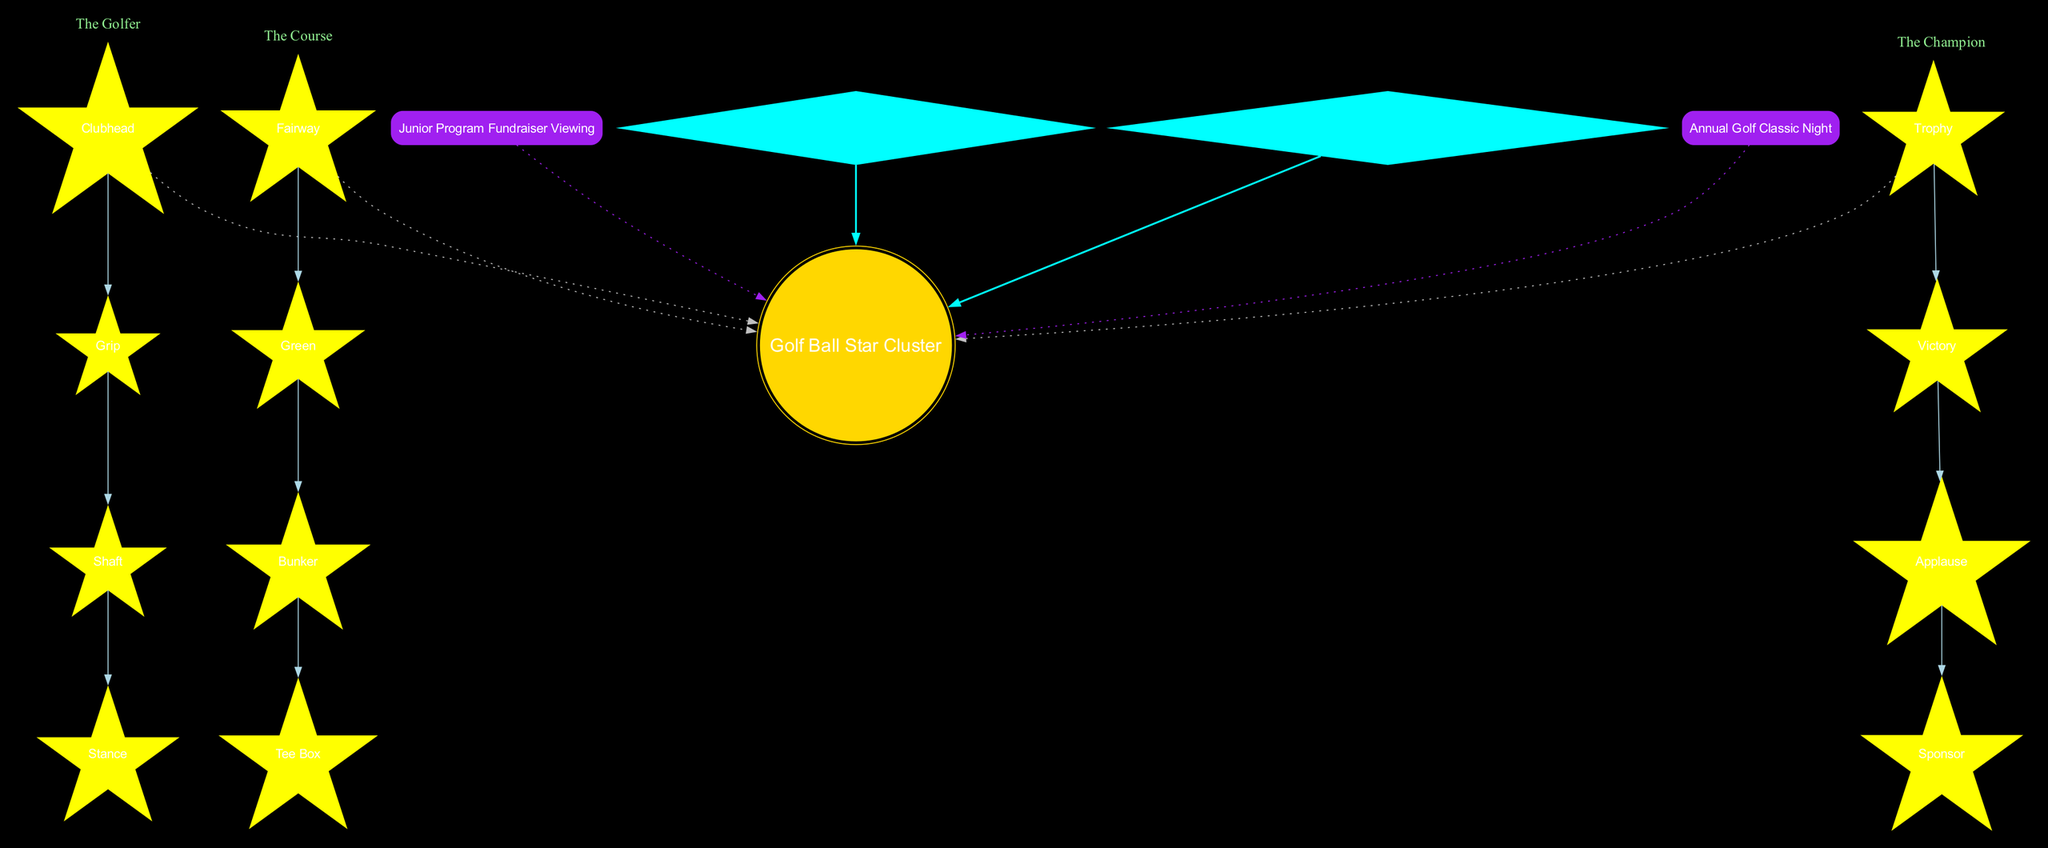What is the central object in the diagram? The central object is labeled as "Golf Ball Star Cluster" at the center of the diagram. It serves as the focal point from which other constellations and notable stars extend.
Answer: Golf Ball Star Cluster How many constellations are represented in the diagram? The diagram shows a total of three constellations: "The Golfer," "The Course," and "The Champion." Each is labeled within its own subgraph.
Answer: 3 What stars are included in "The Champion" constellation? "The Champion" constellation consists of four stars: Trophy, Victory, Applause, and Sponsor. These stars are listed under that specific constellation in the diagram.
Answer: Trophy, Victory, Applause, Sponsor Which star is the brightest in "The Golfer" constellation? The brightest star in "The Golfer" constellation, as indicated in the diagram, is labeled as "Junior Star." It is emphasized in a way that highlights its significance among the other stars.
Answer: Junior Star What color is the "Business Nebula"? According to the diagram, "Business Nebula" is described to be a colorful cloud located near "The Champion" constellation, which indicates a vibrant color representation.
Answer: Colorful Which stargazing event is associated with the junior golf program? The event linked to the junior golf program is explicitly labeled as "Junior Program Fundraiser Viewing" in the diagram, indicating its significance for fundraising purposes.
Answer: Junior Program Fundraiser Viewing How many edges connect the stars in "The Course" constellation? In "The Course" constellation, there are simple connections (edges) drawn between the four listed stars: Fairway, Green, Bunker, and Tee Box, indicating three edges connecting them sequentially.
Answer: 3 Which star in the diagram is associated with the central object using a bold edge? The diagram shows that "Junior Star" is connected to the central object, "Golf Ball Star Cluster," with a bold edge, emphasizing its relationship.
Answer: Junior Star What event is represented by the purple box in the diagram? The purple box in the diagram corresponds to the event labeled "Annual Golf Classic Night," which is one of the stargazing events.
Answer: Annual Golf Classic Night 